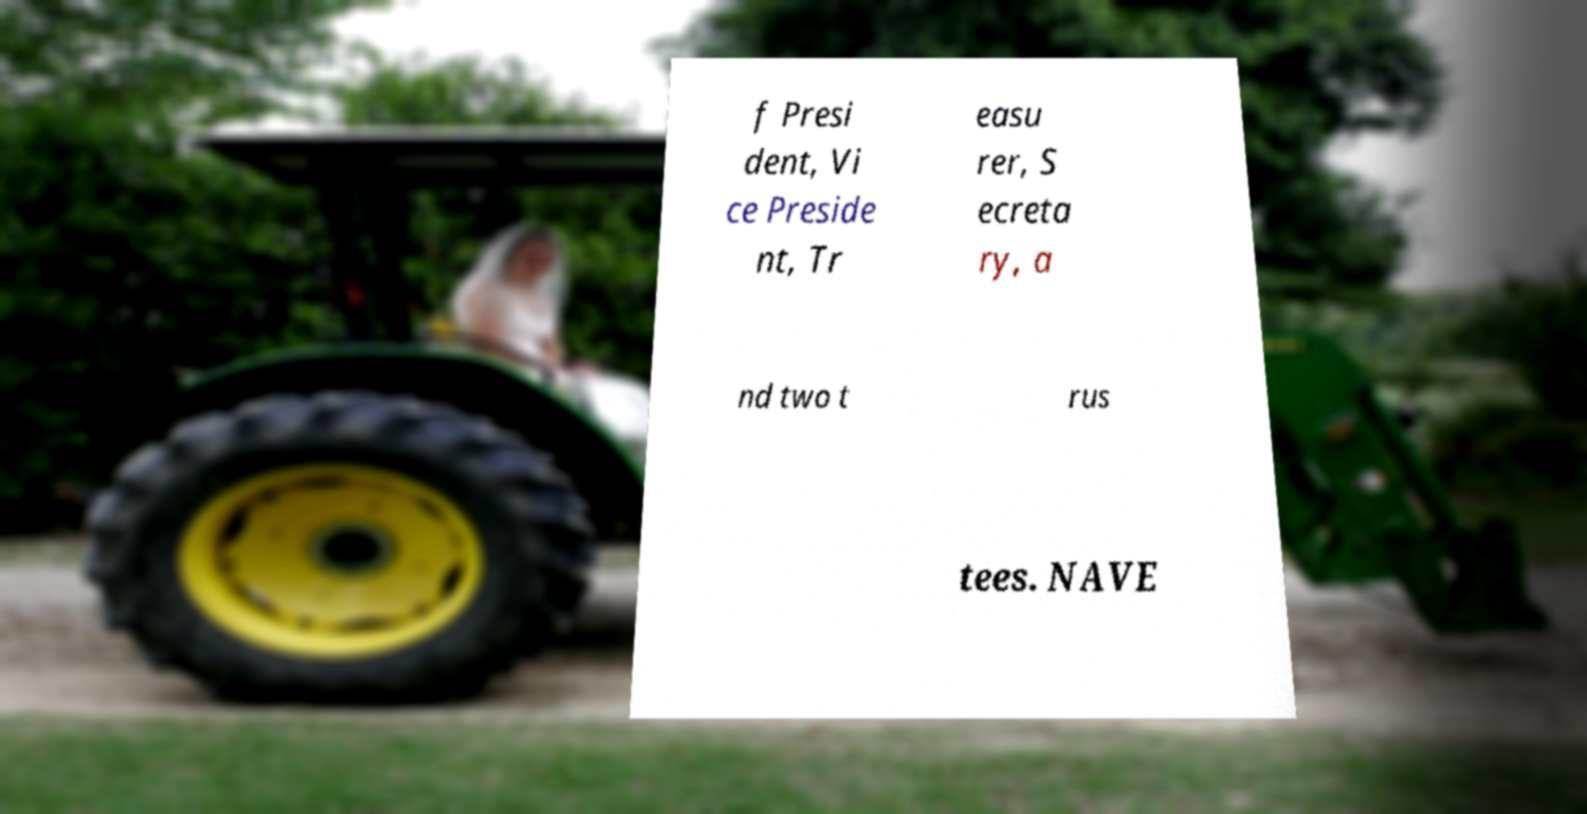For documentation purposes, I need the text within this image transcribed. Could you provide that? f Presi dent, Vi ce Preside nt, Tr easu rer, S ecreta ry, a nd two t rus tees. NAVE 